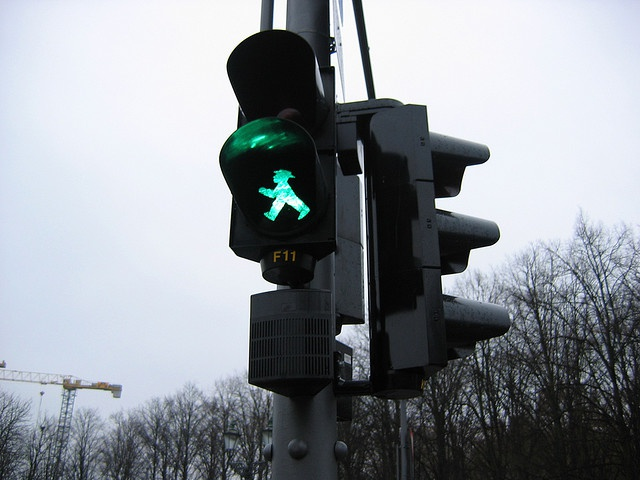Describe the objects in this image and their specific colors. I can see traffic light in lavender, black, darkblue, and gray tones and traffic light in lavender, black, darkgreen, and white tones in this image. 